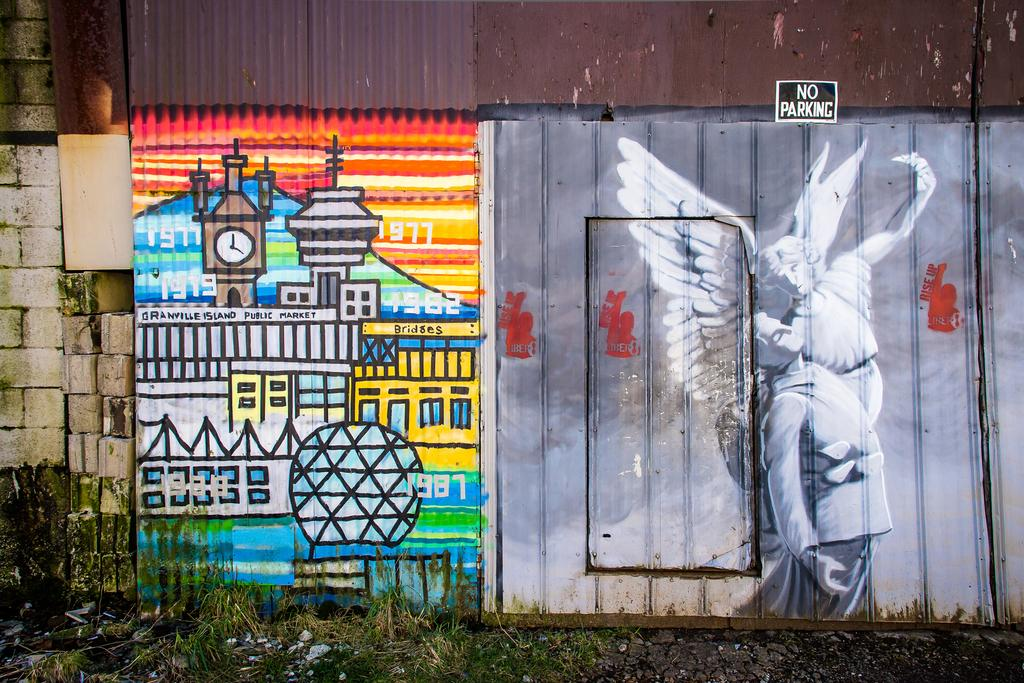What is present on the wall in the image? The wall has different types of paintings on it. Can you describe the phrase visible on the wall? The phrase "No Parking" is visible in the image. How many pigs are present in the image? There are no pigs present in the image. What type of chain is used to secure the paintings on the wall? There is no chain visible in the image; the paintings are simply hanging on the wall. 